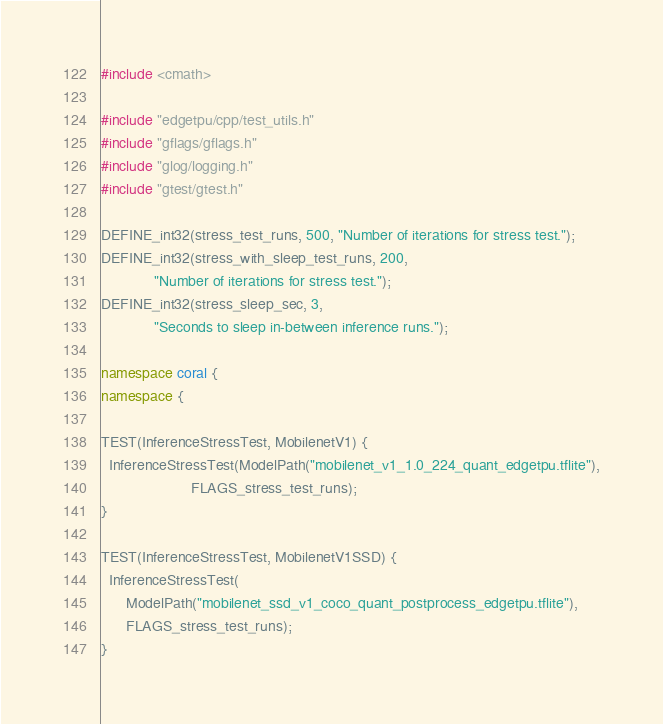<code> <loc_0><loc_0><loc_500><loc_500><_C++_>#include <cmath>

#include "edgetpu/cpp/test_utils.h"
#include "gflags/gflags.h"
#include "glog/logging.h"
#include "gtest/gtest.h"

DEFINE_int32(stress_test_runs, 500, "Number of iterations for stress test.");
DEFINE_int32(stress_with_sleep_test_runs, 200,
             "Number of iterations for stress test.");
DEFINE_int32(stress_sleep_sec, 3,
             "Seconds to sleep in-between inference runs.");

namespace coral {
namespace {

TEST(InferenceStressTest, MobilenetV1) {
  InferenceStressTest(ModelPath("mobilenet_v1_1.0_224_quant_edgetpu.tflite"),
                      FLAGS_stress_test_runs);
}

TEST(InferenceStressTest, MobilenetV1SSD) {
  InferenceStressTest(
      ModelPath("mobilenet_ssd_v1_coco_quant_postprocess_edgetpu.tflite"),
      FLAGS_stress_test_runs);
}
</code> 